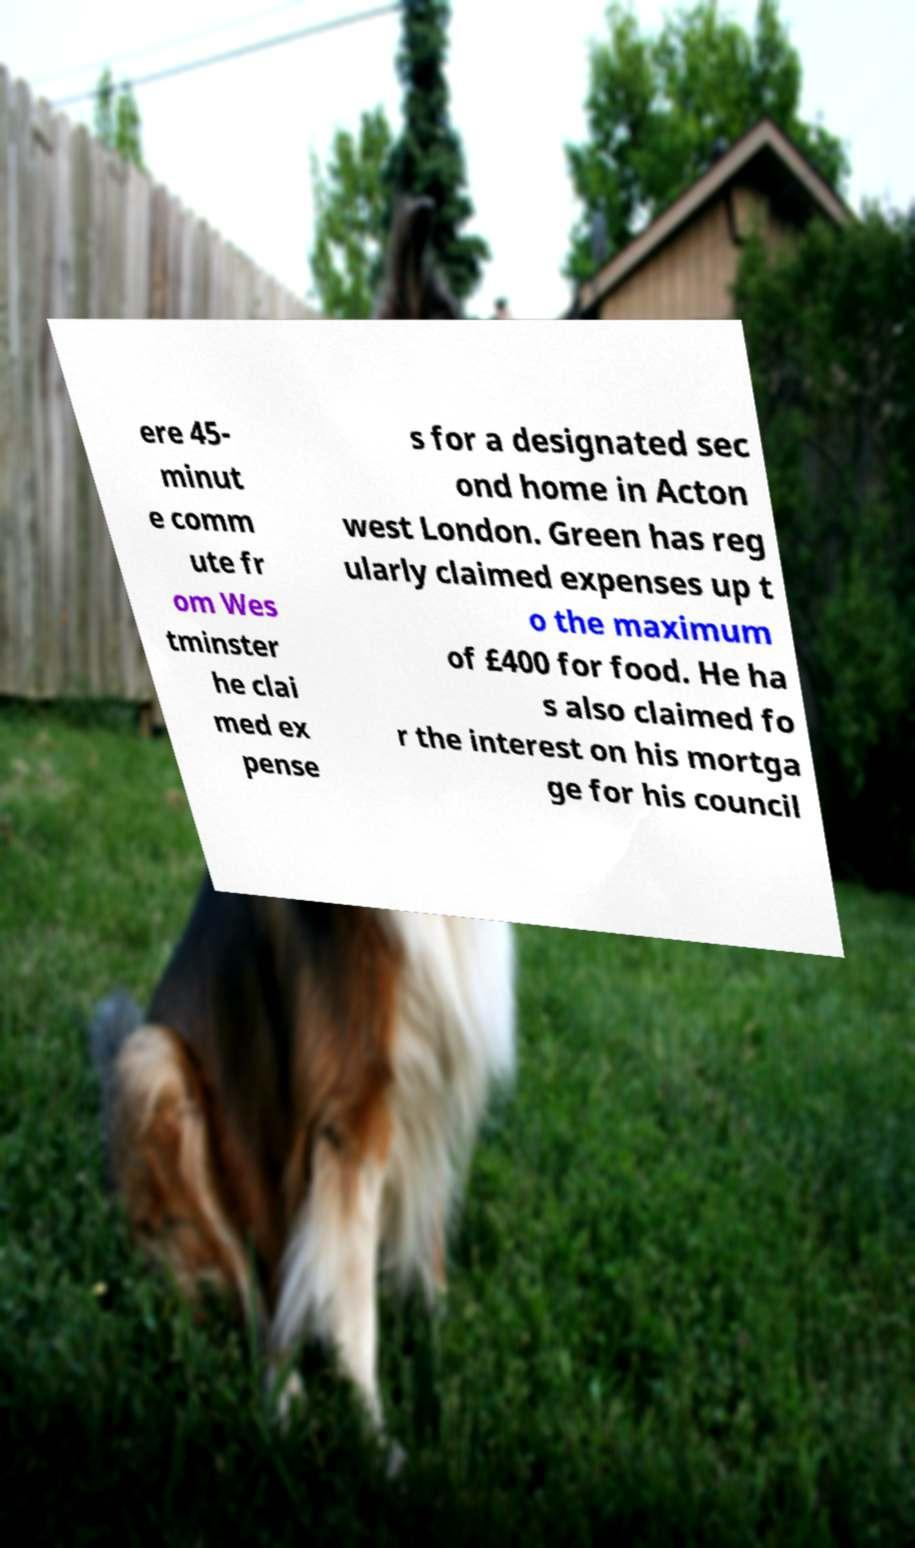For documentation purposes, I need the text within this image transcribed. Could you provide that? ere 45- minut e comm ute fr om Wes tminster he clai med ex pense s for a designated sec ond home in Acton west London. Green has reg ularly claimed expenses up t o the maximum of £400 for food. He ha s also claimed fo r the interest on his mortga ge for his council 